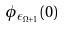<formula> <loc_0><loc_0><loc_500><loc_500>\phi _ { \epsilon _ { \Omega + 1 } } ( 0 )</formula> 